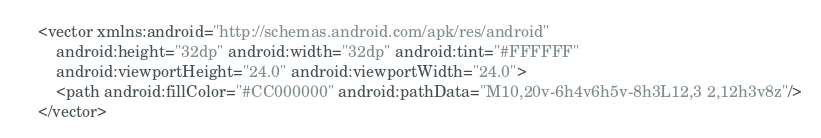<code> <loc_0><loc_0><loc_500><loc_500><_XML_><vector xmlns:android="http://schemas.android.com/apk/res/android"
    android:height="32dp" android:width="32dp" android:tint="#FFFFFF"
    android:viewportHeight="24.0" android:viewportWidth="24.0">
    <path android:fillColor="#CC000000" android:pathData="M10,20v-6h4v6h5v-8h3L12,3 2,12h3v8z"/>
</vector>
</code> 